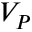Convert formula to latex. <formula><loc_0><loc_0><loc_500><loc_500>V _ { P }</formula> 